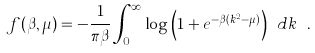<formula> <loc_0><loc_0><loc_500><loc_500>f ( \beta , \mu ) = - \frac { 1 } { \pi \beta } \int _ { 0 } ^ { \infty } \log { \left ( 1 + e ^ { - \beta ( k ^ { 2 } - \mu ) } \right ) } \ d k \ .</formula> 